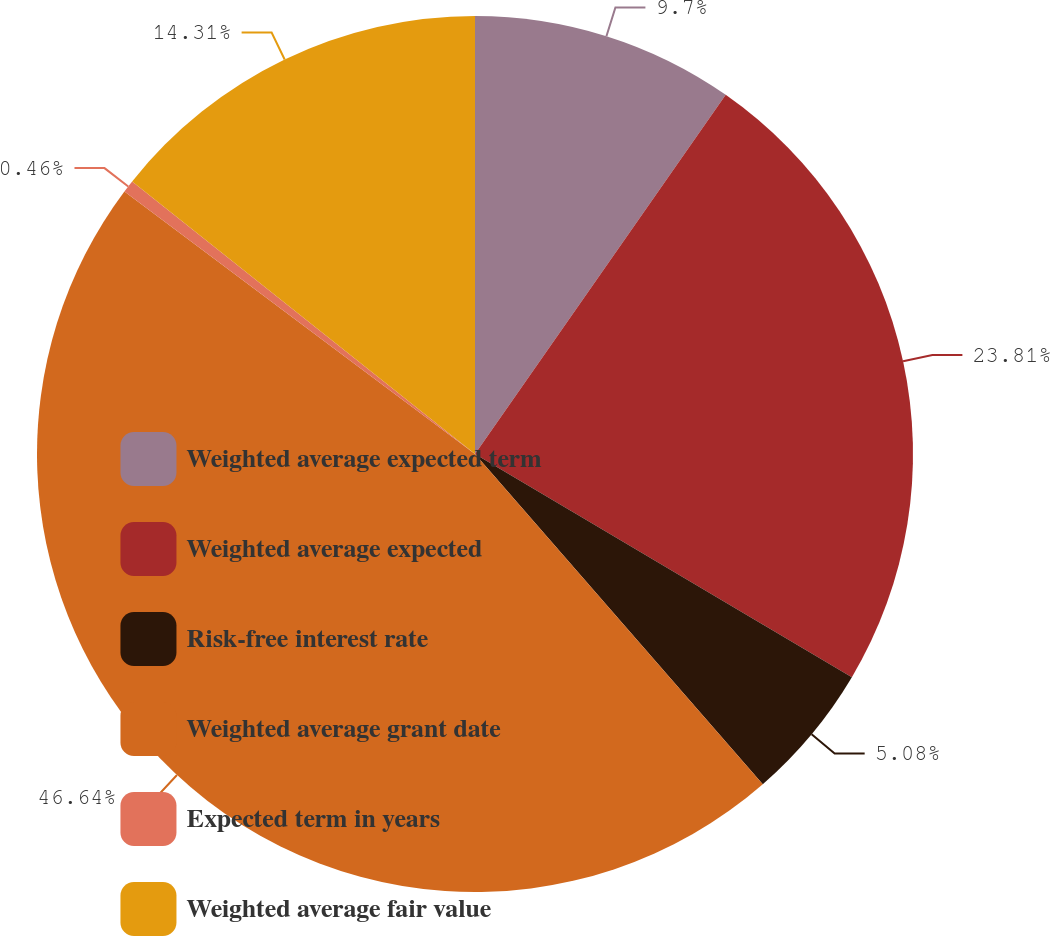Convert chart. <chart><loc_0><loc_0><loc_500><loc_500><pie_chart><fcel>Weighted average expected term<fcel>Weighted average expected<fcel>Risk-free interest rate<fcel>Weighted average grant date<fcel>Expected term in years<fcel>Weighted average fair value<nl><fcel>9.7%<fcel>23.81%<fcel>5.08%<fcel>46.64%<fcel>0.46%<fcel>14.31%<nl></chart> 